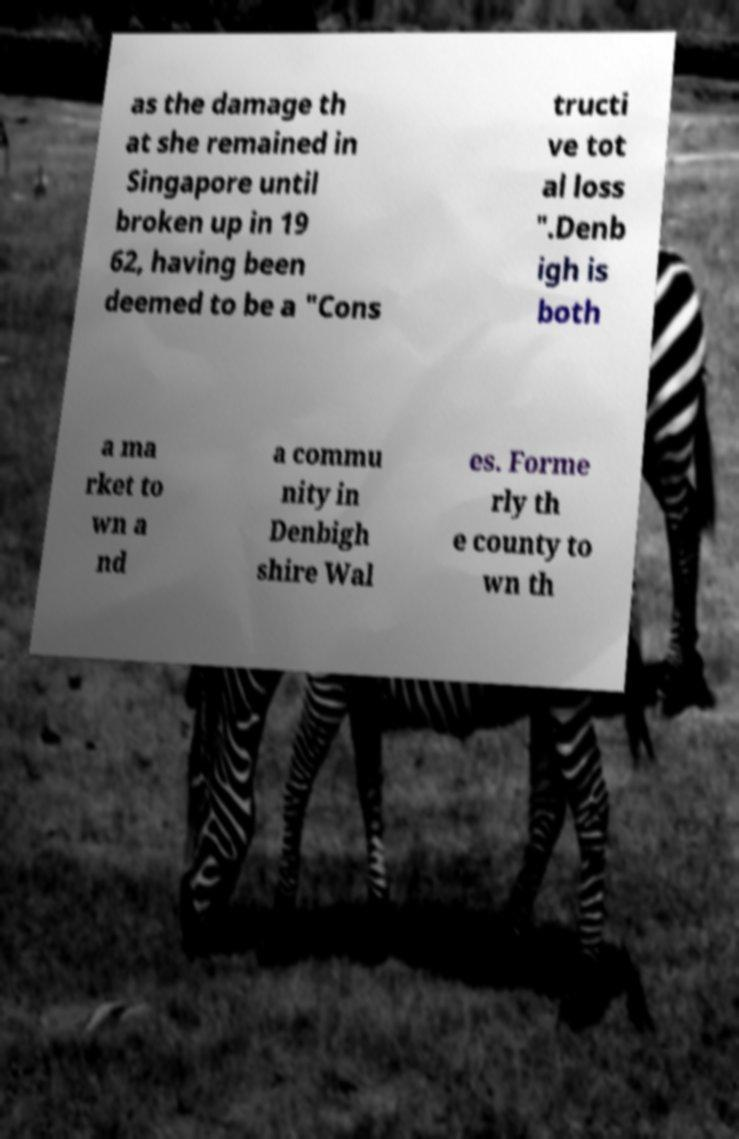Please identify and transcribe the text found in this image. as the damage th at she remained in Singapore until broken up in 19 62, having been deemed to be a "Cons tructi ve tot al loss ".Denb igh is both a ma rket to wn a nd a commu nity in Denbigh shire Wal es. Forme rly th e county to wn th 